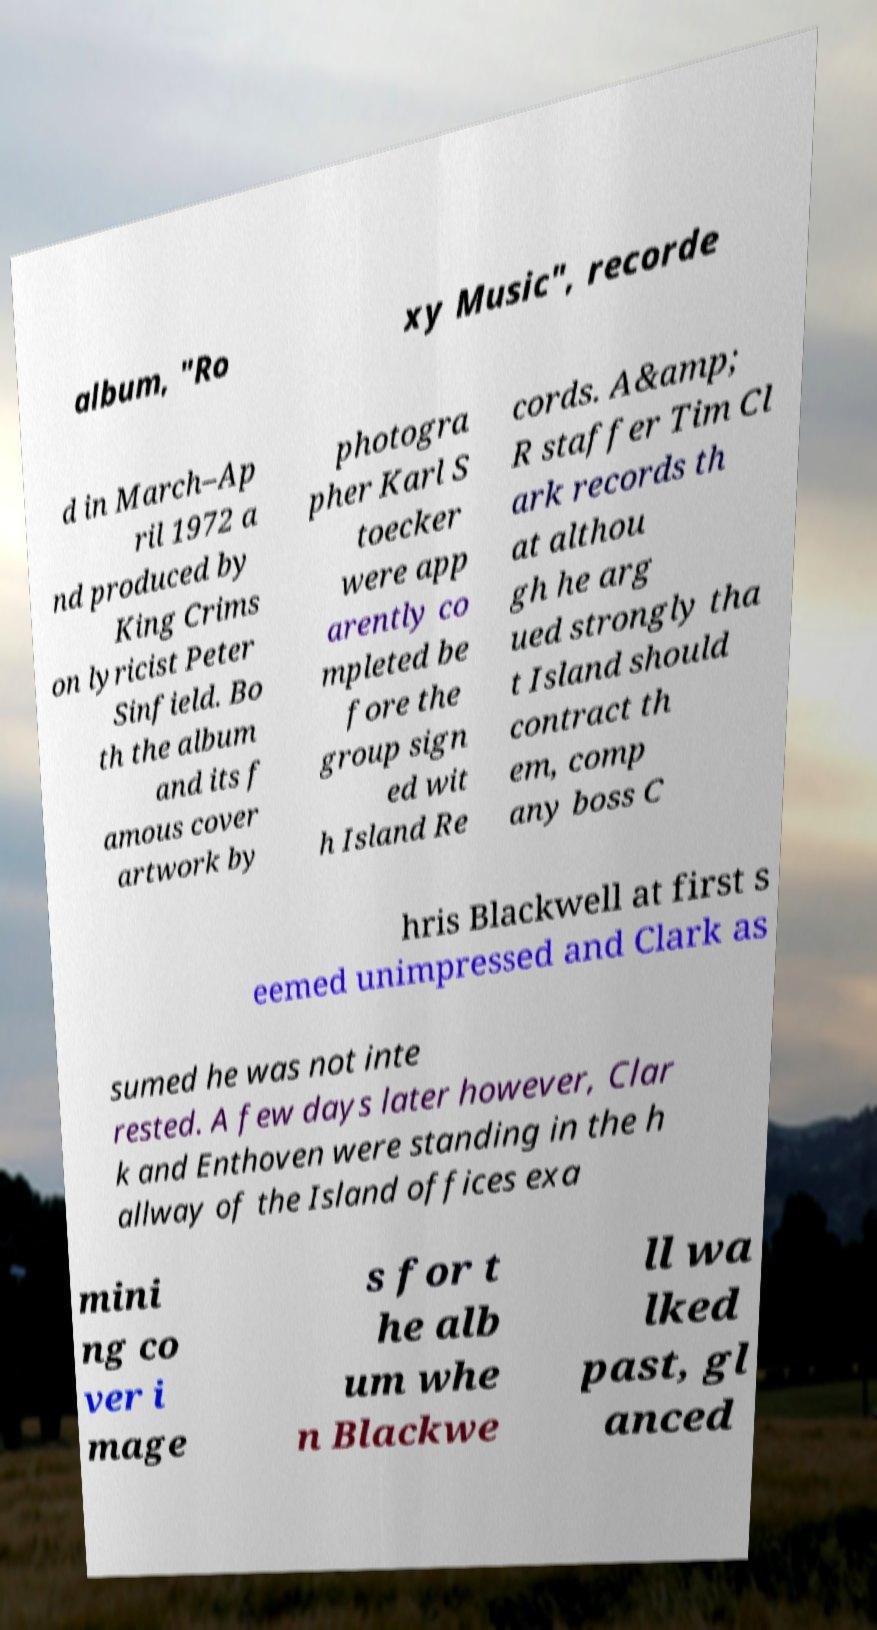Can you accurately transcribe the text from the provided image for me? album, "Ro xy Music", recorde d in March–Ap ril 1972 a nd produced by King Crims on lyricist Peter Sinfield. Bo th the album and its f amous cover artwork by photogra pher Karl S toecker were app arently co mpleted be fore the group sign ed wit h Island Re cords. A&amp; R staffer Tim Cl ark records th at althou gh he arg ued strongly tha t Island should contract th em, comp any boss C hris Blackwell at first s eemed unimpressed and Clark as sumed he was not inte rested. A few days later however, Clar k and Enthoven were standing in the h allway of the Island offices exa mini ng co ver i mage s for t he alb um whe n Blackwe ll wa lked past, gl anced 